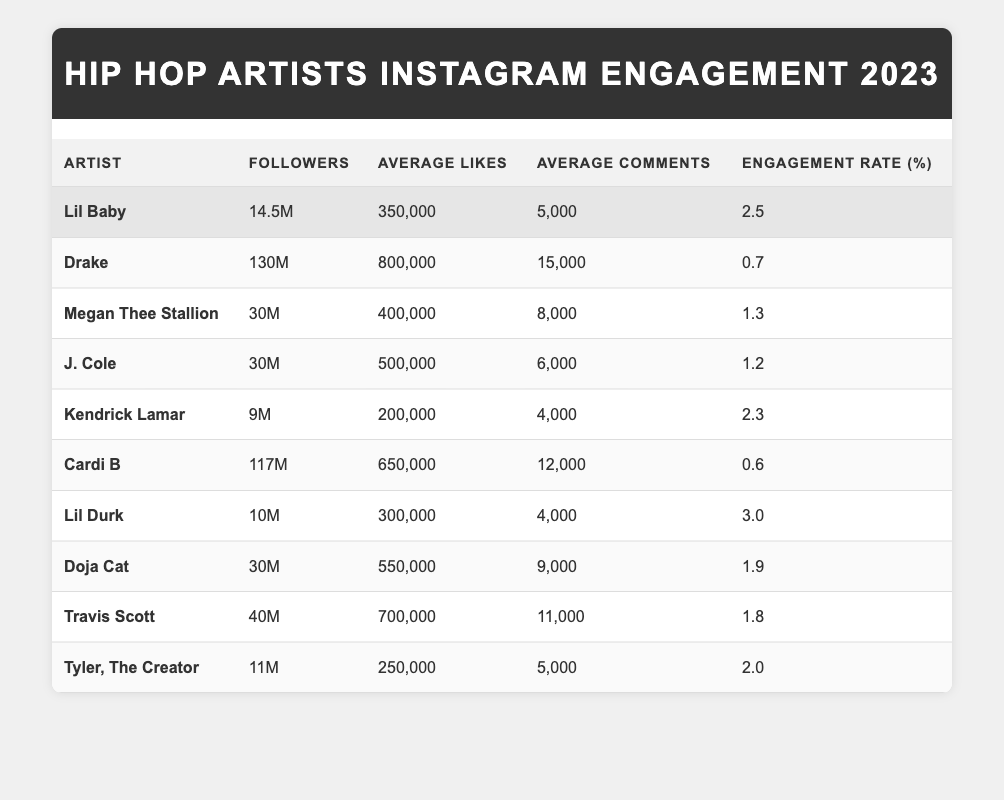What is the engagement rate of Lil Baby? The table shows that Lil Baby has an engagement rate of 2.5%.
Answer: 2.5% How many followers does Travis Scott have? The table indicates that Travis Scott has 40 million followers.
Answer: 40M Which artist has the highest average likes? Drake has the highest average likes with 800,000, according to the table.
Answer: Drake What is the average engagement rate for all the artists listed? To find the average engagement rate, sum up the engagement rates (2.5 + 0.7 + 1.3 + 1.2 + 2.3 + 0.6 + 3.0 + 1.9 + 1.8 + 2.0 = 17.3) and divide by the number of artists (10). The average engagement rate is 17.3/10 = 1.73%.
Answer: 1.73% Does Megan Thee Stallion have more followers than J. Cole? Megan Thee Stallion has 30 million followers, and J. Cole also has 30 million, so they are equal.
Answer: No Which artist has the lowest average comments? The table reveals that Kendrick Lamar has the lowest average comments with 4,000.
Answer: Kendrick Lamar Is Lil Durk's engagement rate higher than Cardi B's? Lil Durk has an engagement rate of 3.0%, while Cardi B has 0.6%. Since 3.0% is greater than 0.6%, Lil Durk does have a higher engagement rate than Cardi B.
Answer: Yes What is the difference in followers between Drake and Lil Baby? Drake has 130 million followers, and Lil Baby has 14.5 million. The difference is calculated by subtracting Lil Baby’s followers from Drake's: 130 - 14.5 = 115.5 million.
Answer: 115.5M Which two artists have the highest engagement rates, and what are they? Lil Durk has 3.0% and Lil Baby has 2.5%. These are the two highest engagement rates from the table.
Answer: Lil Durk (3.0%), Lil Baby (2.5%) How many total average likes do the top 5 artists have combined? The top 5 artists are: Drake (800,000), Lil Baby (350,000), Megan Thee Stallion (400,000), J. Cole (500,000), and Kendrick Lamar (200,000). Summing their average likes gives (800,000 + 350,000 + 400,000 + 500,000 + 200,000 = 2,250,000).
Answer: 2,250,000 